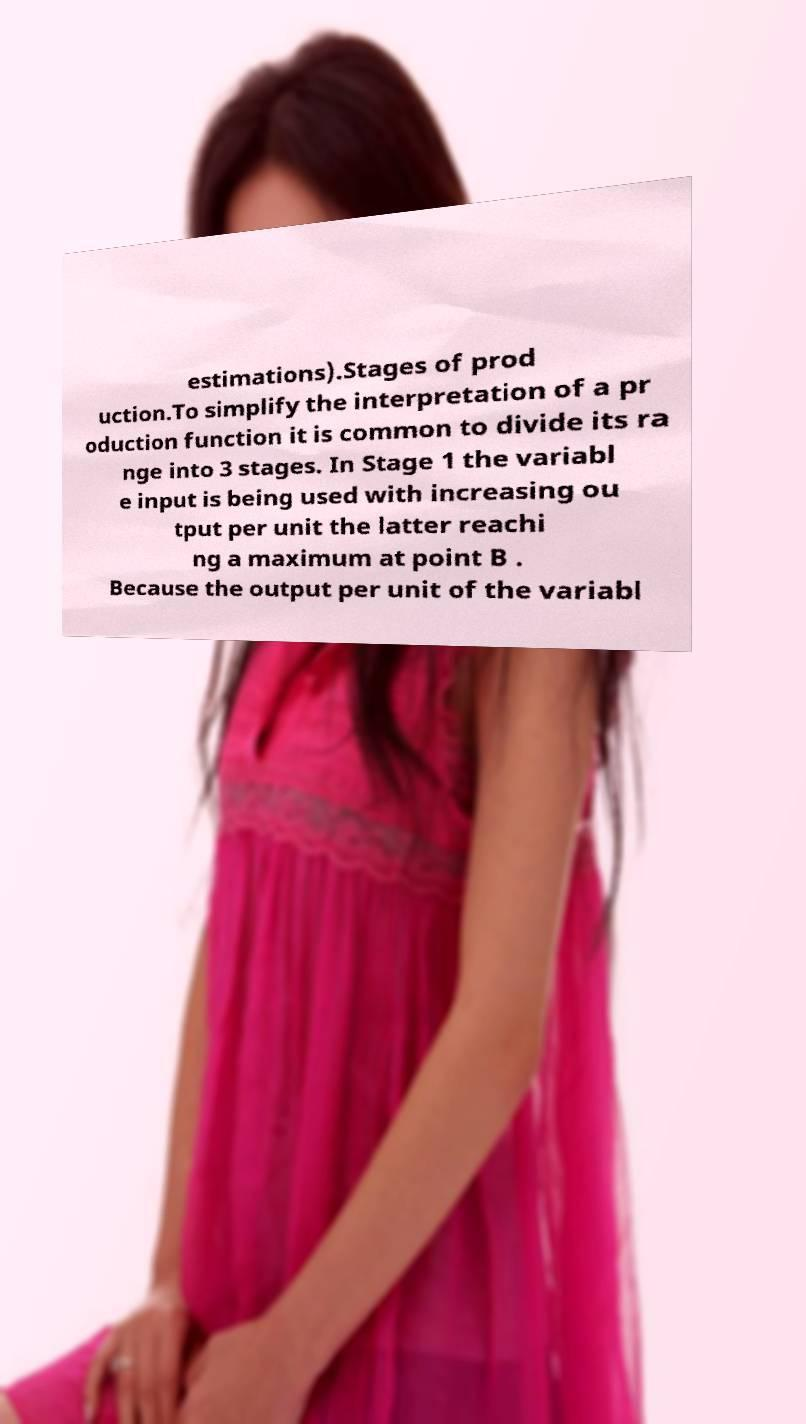Could you extract and type out the text from this image? estimations).Stages of prod uction.To simplify the interpretation of a pr oduction function it is common to divide its ra nge into 3 stages. In Stage 1 the variabl e input is being used with increasing ou tput per unit the latter reachi ng a maximum at point B . Because the output per unit of the variabl 